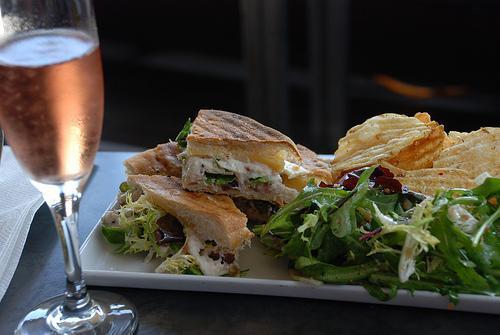How many glasses are there?
Give a very brief answer. 1. 